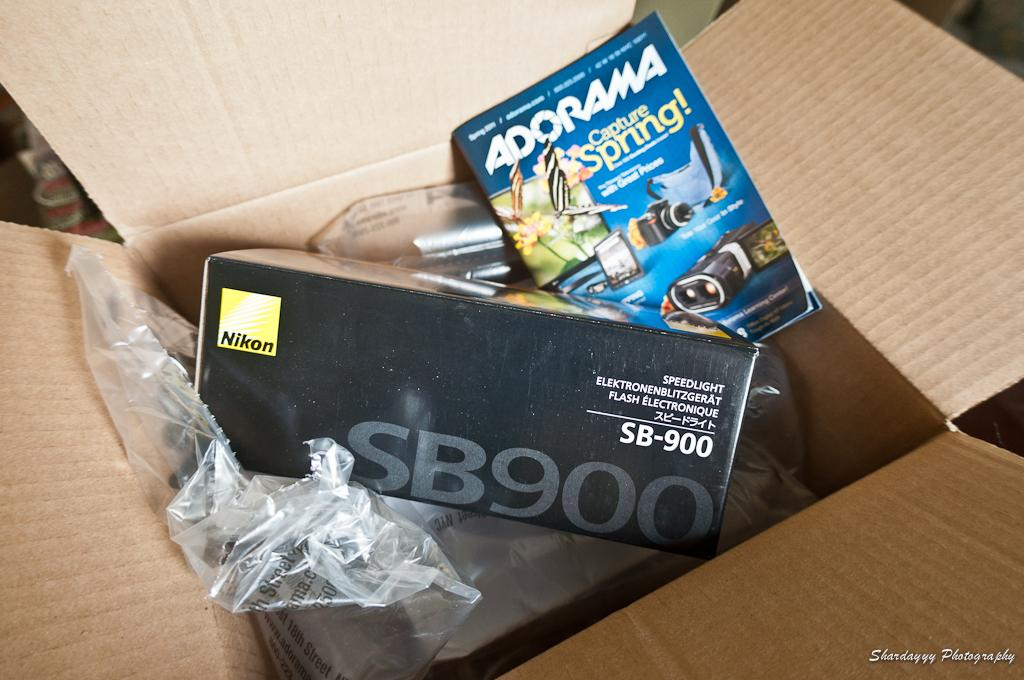<image>
Offer a succinct explanation of the picture presented. An Adorama Capture spring booklet and a Nikon box are in a brown cardboard box. 